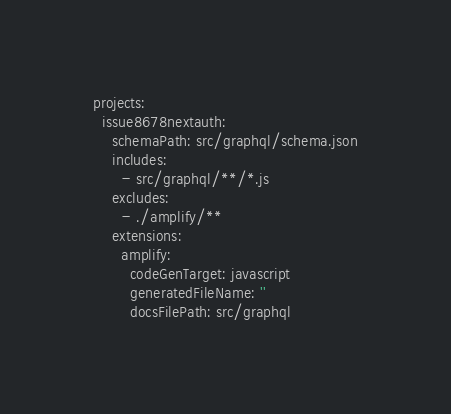Convert code to text. <code><loc_0><loc_0><loc_500><loc_500><_YAML_>projects:
  issue8678nextauth:
    schemaPath: src/graphql/schema.json
    includes:
      - src/graphql/**/*.js
    excludes:
      - ./amplify/**
    extensions:
      amplify:
        codeGenTarget: javascript
        generatedFileName: ''
        docsFilePath: src/graphql
</code> 